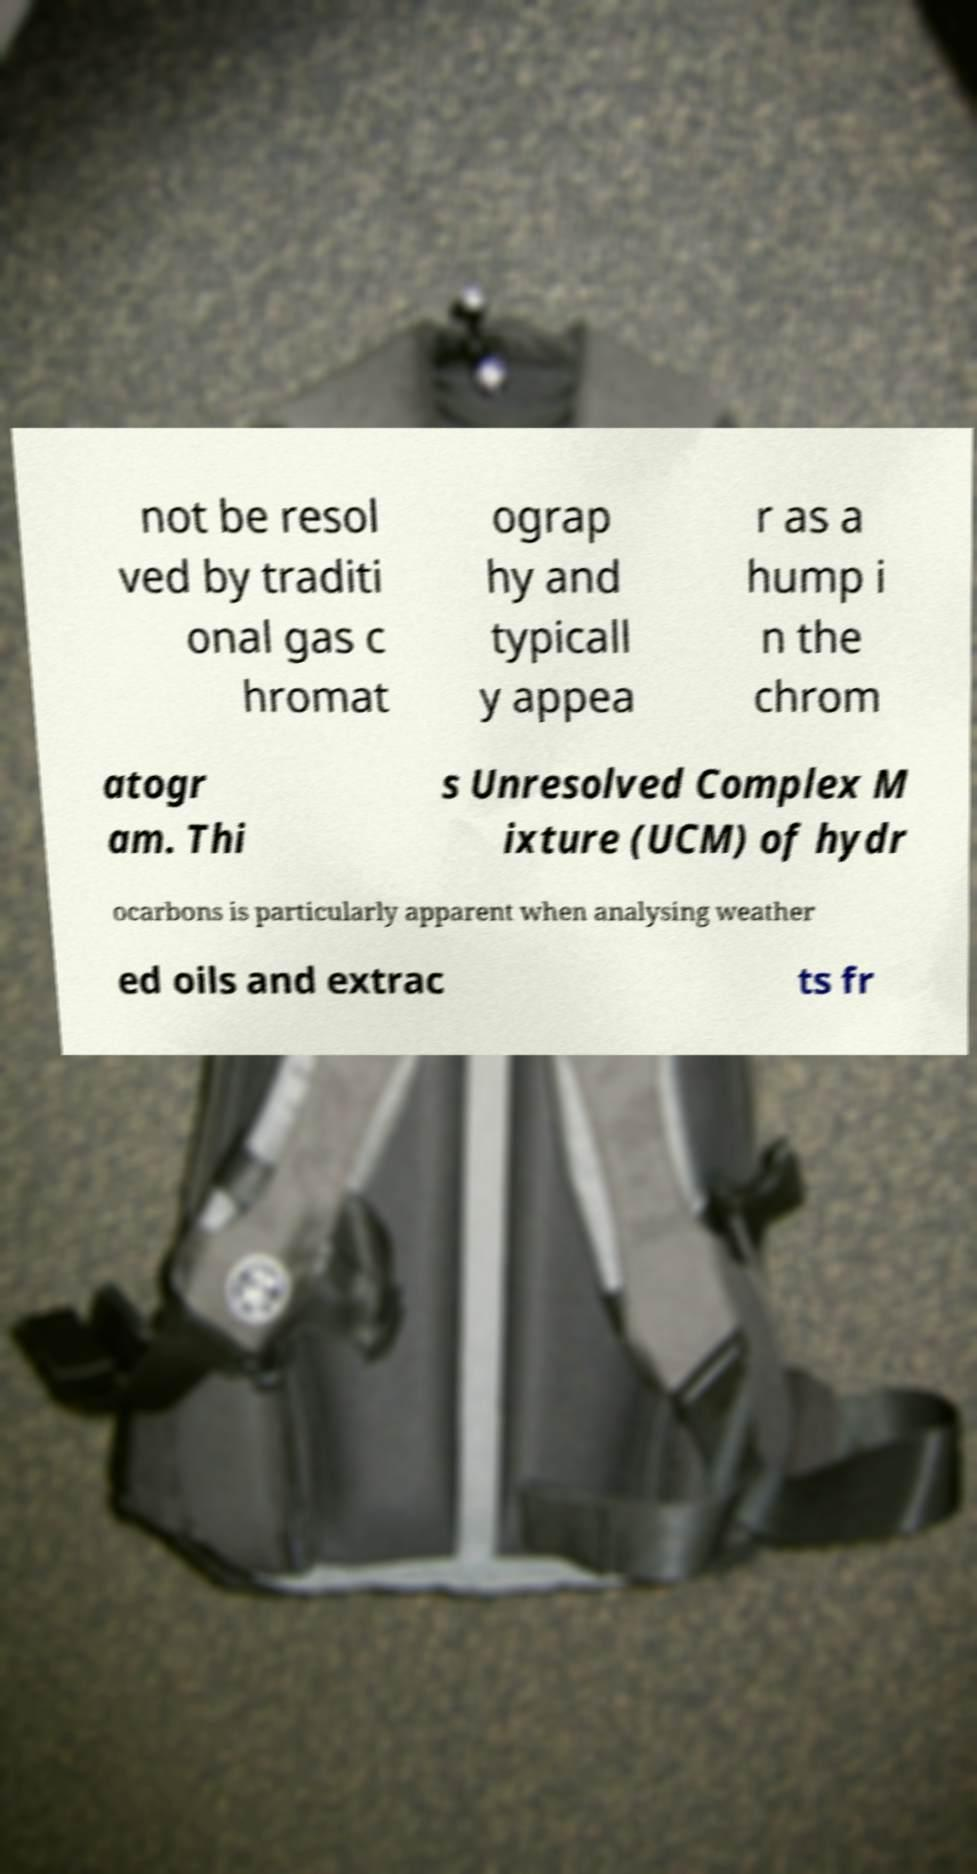I need the written content from this picture converted into text. Can you do that? not be resol ved by traditi onal gas c hromat ograp hy and typicall y appea r as a hump i n the chrom atogr am. Thi s Unresolved Complex M ixture (UCM) of hydr ocarbons is particularly apparent when analysing weather ed oils and extrac ts fr 